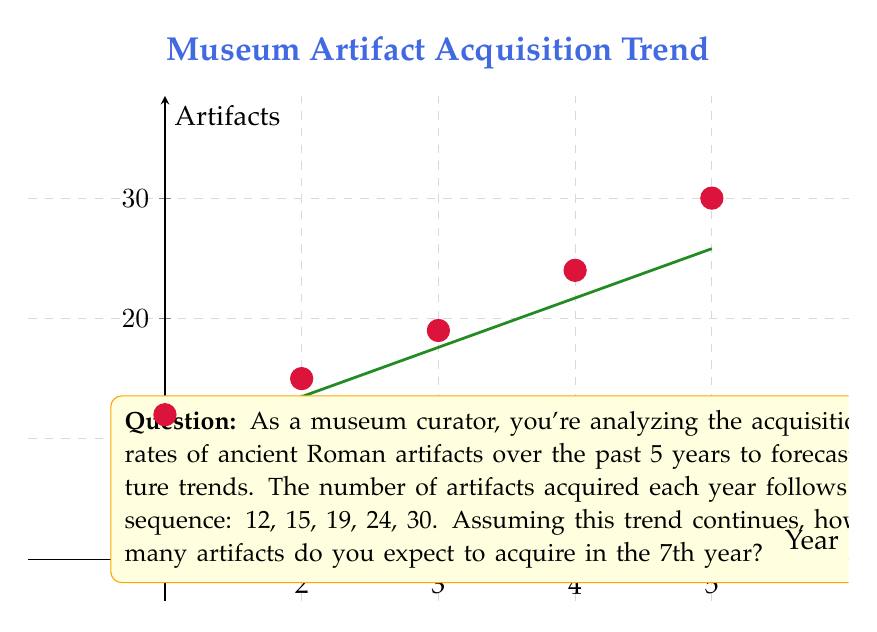Provide a solution to this math problem. To forecast the number of artifacts for the 7th year, we need to identify the pattern in the given sequence and extend it. Let's approach this step-by-step:

1) First, let's calculate the differences between consecutive terms:
   15 - 12 = 3
   19 - 15 = 4
   24 - 19 = 5
   30 - 24 = 6

2) We observe that the differences are increasing by 1 each time. This suggests a quadratic sequence.

3) For a quadratic sequence of the form $a_n = an^2 + bn + c$, we can use the method of differences to find $a$, $b$, and $c$.

4) The second differences are constant:
   4 - 3 = 1
   5 - 4 = 1
   6 - 5 = 1

5) For a quadratic sequence, $a = \frac{1}{2}$ of the second difference. So, $a = \frac{1}{2}$.

6) Now we can set up a system of equations using the first three terms:
   $12 = \frac{1}{2}(1)^2 + b(1) + c$
   $15 = \frac{1}{2}(2)^2 + b(2) + c$
   $19 = \frac{1}{2}(3)^2 + b(3) + c$

7) Solving this system (you can use substitution or elimination), we get:
   $b = \frac{5}{2}$ and $c = 9$

8) Therefore, our sequence follows the formula:
   $a_n = \frac{1}{2}n^2 + \frac{5}{2}n + 9$

9) To find the 7th term, we substitute $n = 7$:
   $a_7 = \frac{1}{2}(7)^2 + \frac{5}{2}(7) + 9$
        $= \frac{49}{2} + \frac{35}{2} + 9$
        $= 24.5 + 17.5 + 9$
        $= 51$

Therefore, in the 7th year, we expect to acquire 51 artifacts.
Answer: 51 artifacts 